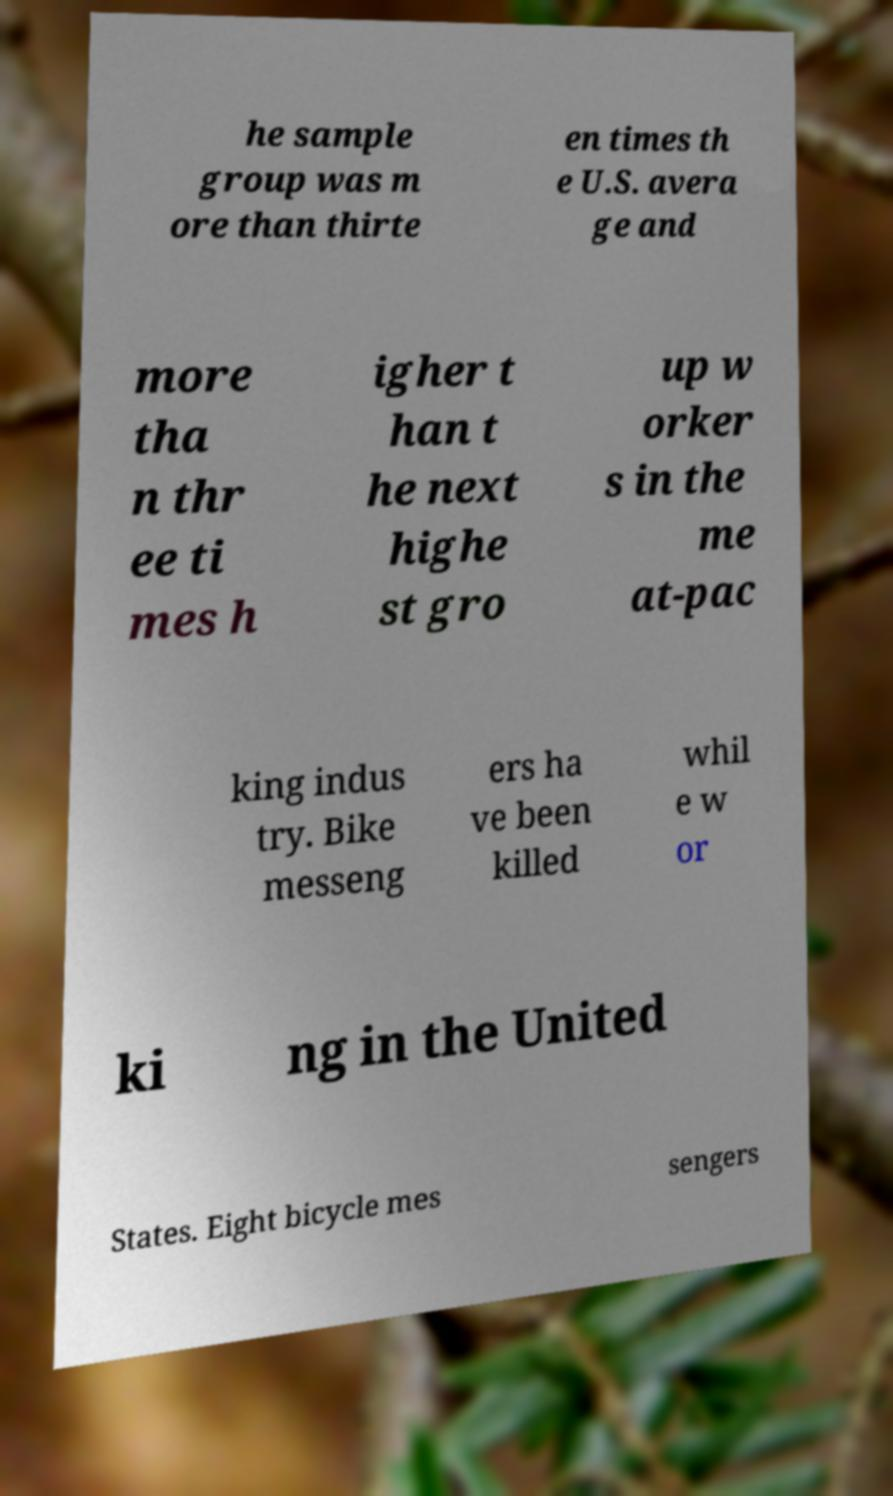Can you accurately transcribe the text from the provided image for me? he sample group was m ore than thirte en times th e U.S. avera ge and more tha n thr ee ti mes h igher t han t he next highe st gro up w orker s in the me at-pac king indus try. Bike messeng ers ha ve been killed whil e w or ki ng in the United States. Eight bicycle mes sengers 